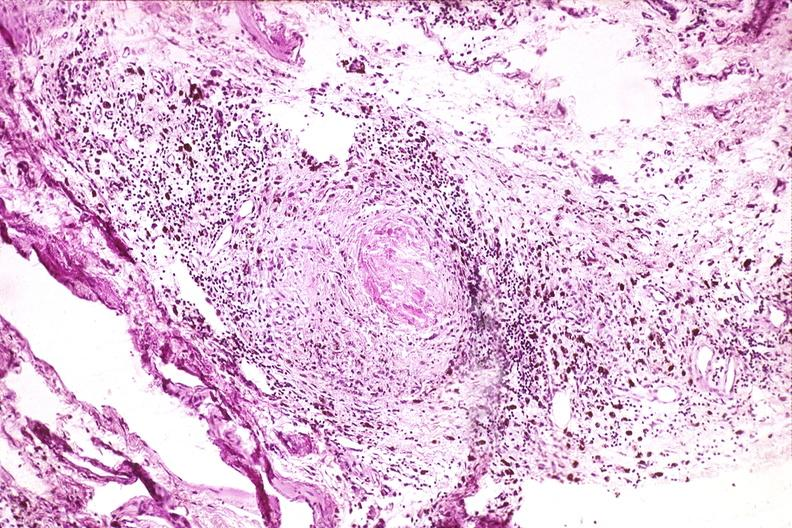what does this image show?
Answer the question using a single word or phrase. Synovium 